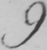What is written in this line of handwriting? 9 . 